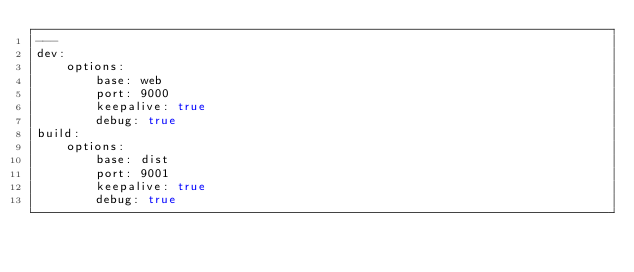<code> <loc_0><loc_0><loc_500><loc_500><_YAML_>---
dev:
    options:
        base: web
        port: 9000
        keepalive: true
        debug: true
build:
    options:
        base: dist
        port: 9001
        keepalive: true
        debug: true
</code> 